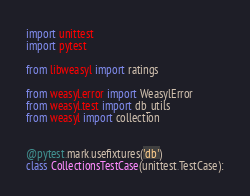Convert code to text. <code><loc_0><loc_0><loc_500><loc_500><_Python_>import unittest
import pytest

from libweasyl import ratings

from weasyl.error import WeasylError
from weasyl.test import db_utils
from weasyl import collection


@pytest.mark.usefixtures('db')
class CollectionsTestCase(unittest.TestCase):</code> 